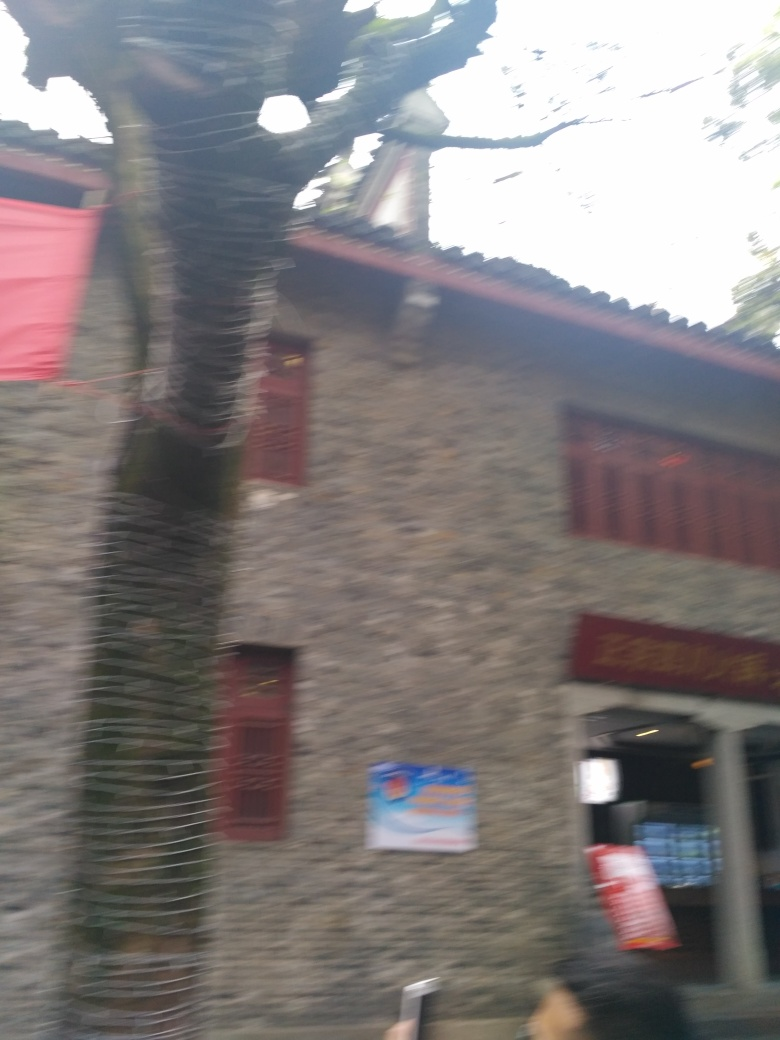Is there anything in this image that indicates the location where it was taken? The architecture style of the building, along with the traditional red banners, suggests that this image could have been taken in a region with historic or cultural significance, potentially in East Asia. However, without clearer visual details, the exact location cannot be confirmed. 